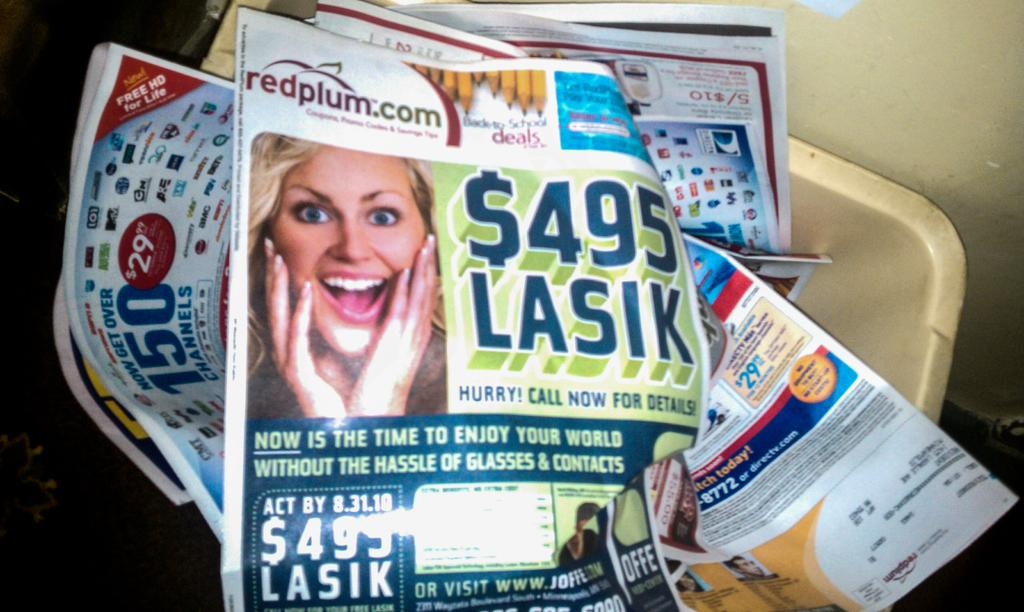What can be seen hanging on the walls in the image? There are posters in the image. Where are the posters located? The posters are inside a container. What type of cork can be seen on the posters in the image? There is no cork present on the posters in the image. What type of cloth is used to make the posters in the image? The posters in the image are not made of cloth; they are likely printed on paper or another material. 